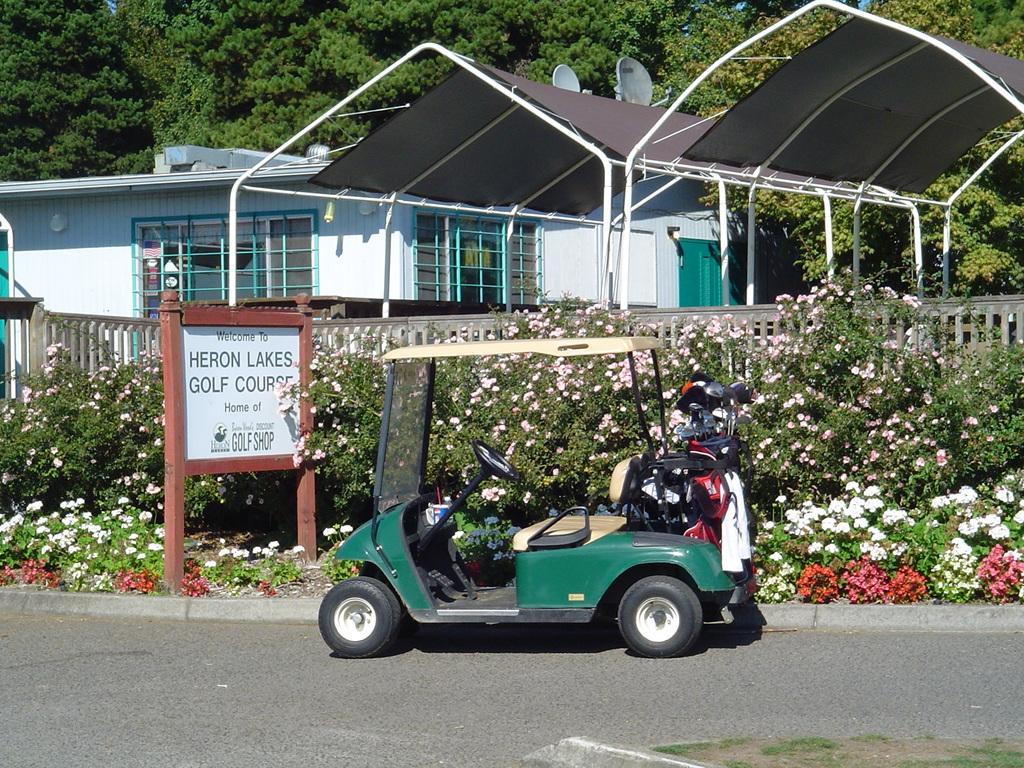Can you describe this image briefly? In this image I can see few sheds, house, windows, trees, fencing, board, vehicle and white and red color flowers. 